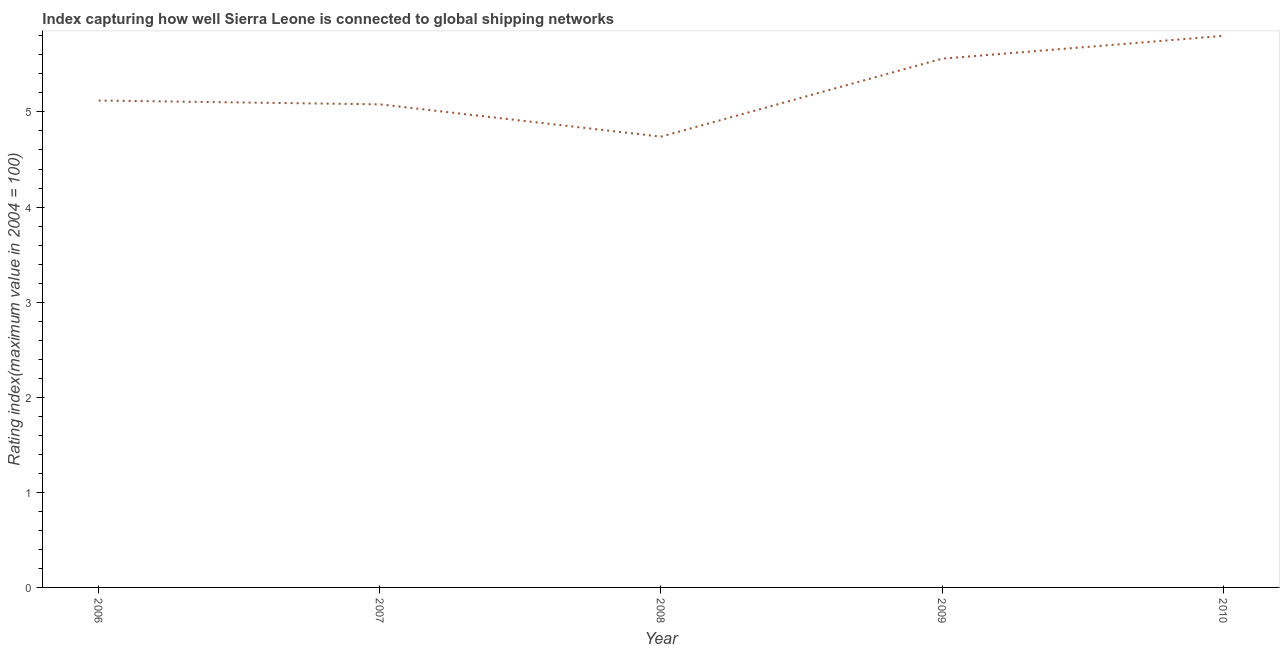Across all years, what is the maximum liner shipping connectivity index?
Ensure brevity in your answer.  5.8. Across all years, what is the minimum liner shipping connectivity index?
Provide a short and direct response. 4.74. In which year was the liner shipping connectivity index minimum?
Provide a short and direct response. 2008. What is the sum of the liner shipping connectivity index?
Your answer should be compact. 26.3. What is the difference between the liner shipping connectivity index in 2006 and 2009?
Offer a terse response. -0.44. What is the average liner shipping connectivity index per year?
Provide a short and direct response. 5.26. What is the median liner shipping connectivity index?
Provide a short and direct response. 5.12. In how many years, is the liner shipping connectivity index greater than 3 ?
Your answer should be very brief. 5. What is the ratio of the liner shipping connectivity index in 2008 to that in 2010?
Offer a very short reply. 0.82. Is the difference between the liner shipping connectivity index in 2008 and 2010 greater than the difference between any two years?
Make the answer very short. Yes. What is the difference between the highest and the second highest liner shipping connectivity index?
Provide a short and direct response. 0.24. Is the sum of the liner shipping connectivity index in 2009 and 2010 greater than the maximum liner shipping connectivity index across all years?
Offer a terse response. Yes. What is the difference between the highest and the lowest liner shipping connectivity index?
Keep it short and to the point. 1.06. Does the liner shipping connectivity index monotonically increase over the years?
Keep it short and to the point. No. What is the title of the graph?
Provide a succinct answer. Index capturing how well Sierra Leone is connected to global shipping networks. What is the label or title of the Y-axis?
Make the answer very short. Rating index(maximum value in 2004 = 100). What is the Rating index(maximum value in 2004 = 100) of 2006?
Offer a terse response. 5.12. What is the Rating index(maximum value in 2004 = 100) in 2007?
Your answer should be very brief. 5.08. What is the Rating index(maximum value in 2004 = 100) of 2008?
Make the answer very short. 4.74. What is the Rating index(maximum value in 2004 = 100) in 2009?
Ensure brevity in your answer.  5.56. What is the Rating index(maximum value in 2004 = 100) of 2010?
Provide a succinct answer. 5.8. What is the difference between the Rating index(maximum value in 2004 = 100) in 2006 and 2008?
Keep it short and to the point. 0.38. What is the difference between the Rating index(maximum value in 2004 = 100) in 2006 and 2009?
Provide a succinct answer. -0.44. What is the difference between the Rating index(maximum value in 2004 = 100) in 2006 and 2010?
Keep it short and to the point. -0.68. What is the difference between the Rating index(maximum value in 2004 = 100) in 2007 and 2008?
Provide a short and direct response. 0.34. What is the difference between the Rating index(maximum value in 2004 = 100) in 2007 and 2009?
Provide a short and direct response. -0.48. What is the difference between the Rating index(maximum value in 2004 = 100) in 2007 and 2010?
Ensure brevity in your answer.  -0.72. What is the difference between the Rating index(maximum value in 2004 = 100) in 2008 and 2009?
Provide a succinct answer. -0.82. What is the difference between the Rating index(maximum value in 2004 = 100) in 2008 and 2010?
Provide a succinct answer. -1.06. What is the difference between the Rating index(maximum value in 2004 = 100) in 2009 and 2010?
Offer a terse response. -0.24. What is the ratio of the Rating index(maximum value in 2004 = 100) in 2006 to that in 2009?
Give a very brief answer. 0.92. What is the ratio of the Rating index(maximum value in 2004 = 100) in 2006 to that in 2010?
Offer a very short reply. 0.88. What is the ratio of the Rating index(maximum value in 2004 = 100) in 2007 to that in 2008?
Your response must be concise. 1.07. What is the ratio of the Rating index(maximum value in 2004 = 100) in 2007 to that in 2009?
Offer a terse response. 0.91. What is the ratio of the Rating index(maximum value in 2004 = 100) in 2007 to that in 2010?
Your answer should be compact. 0.88. What is the ratio of the Rating index(maximum value in 2004 = 100) in 2008 to that in 2009?
Keep it short and to the point. 0.85. What is the ratio of the Rating index(maximum value in 2004 = 100) in 2008 to that in 2010?
Your answer should be compact. 0.82. What is the ratio of the Rating index(maximum value in 2004 = 100) in 2009 to that in 2010?
Offer a very short reply. 0.96. 